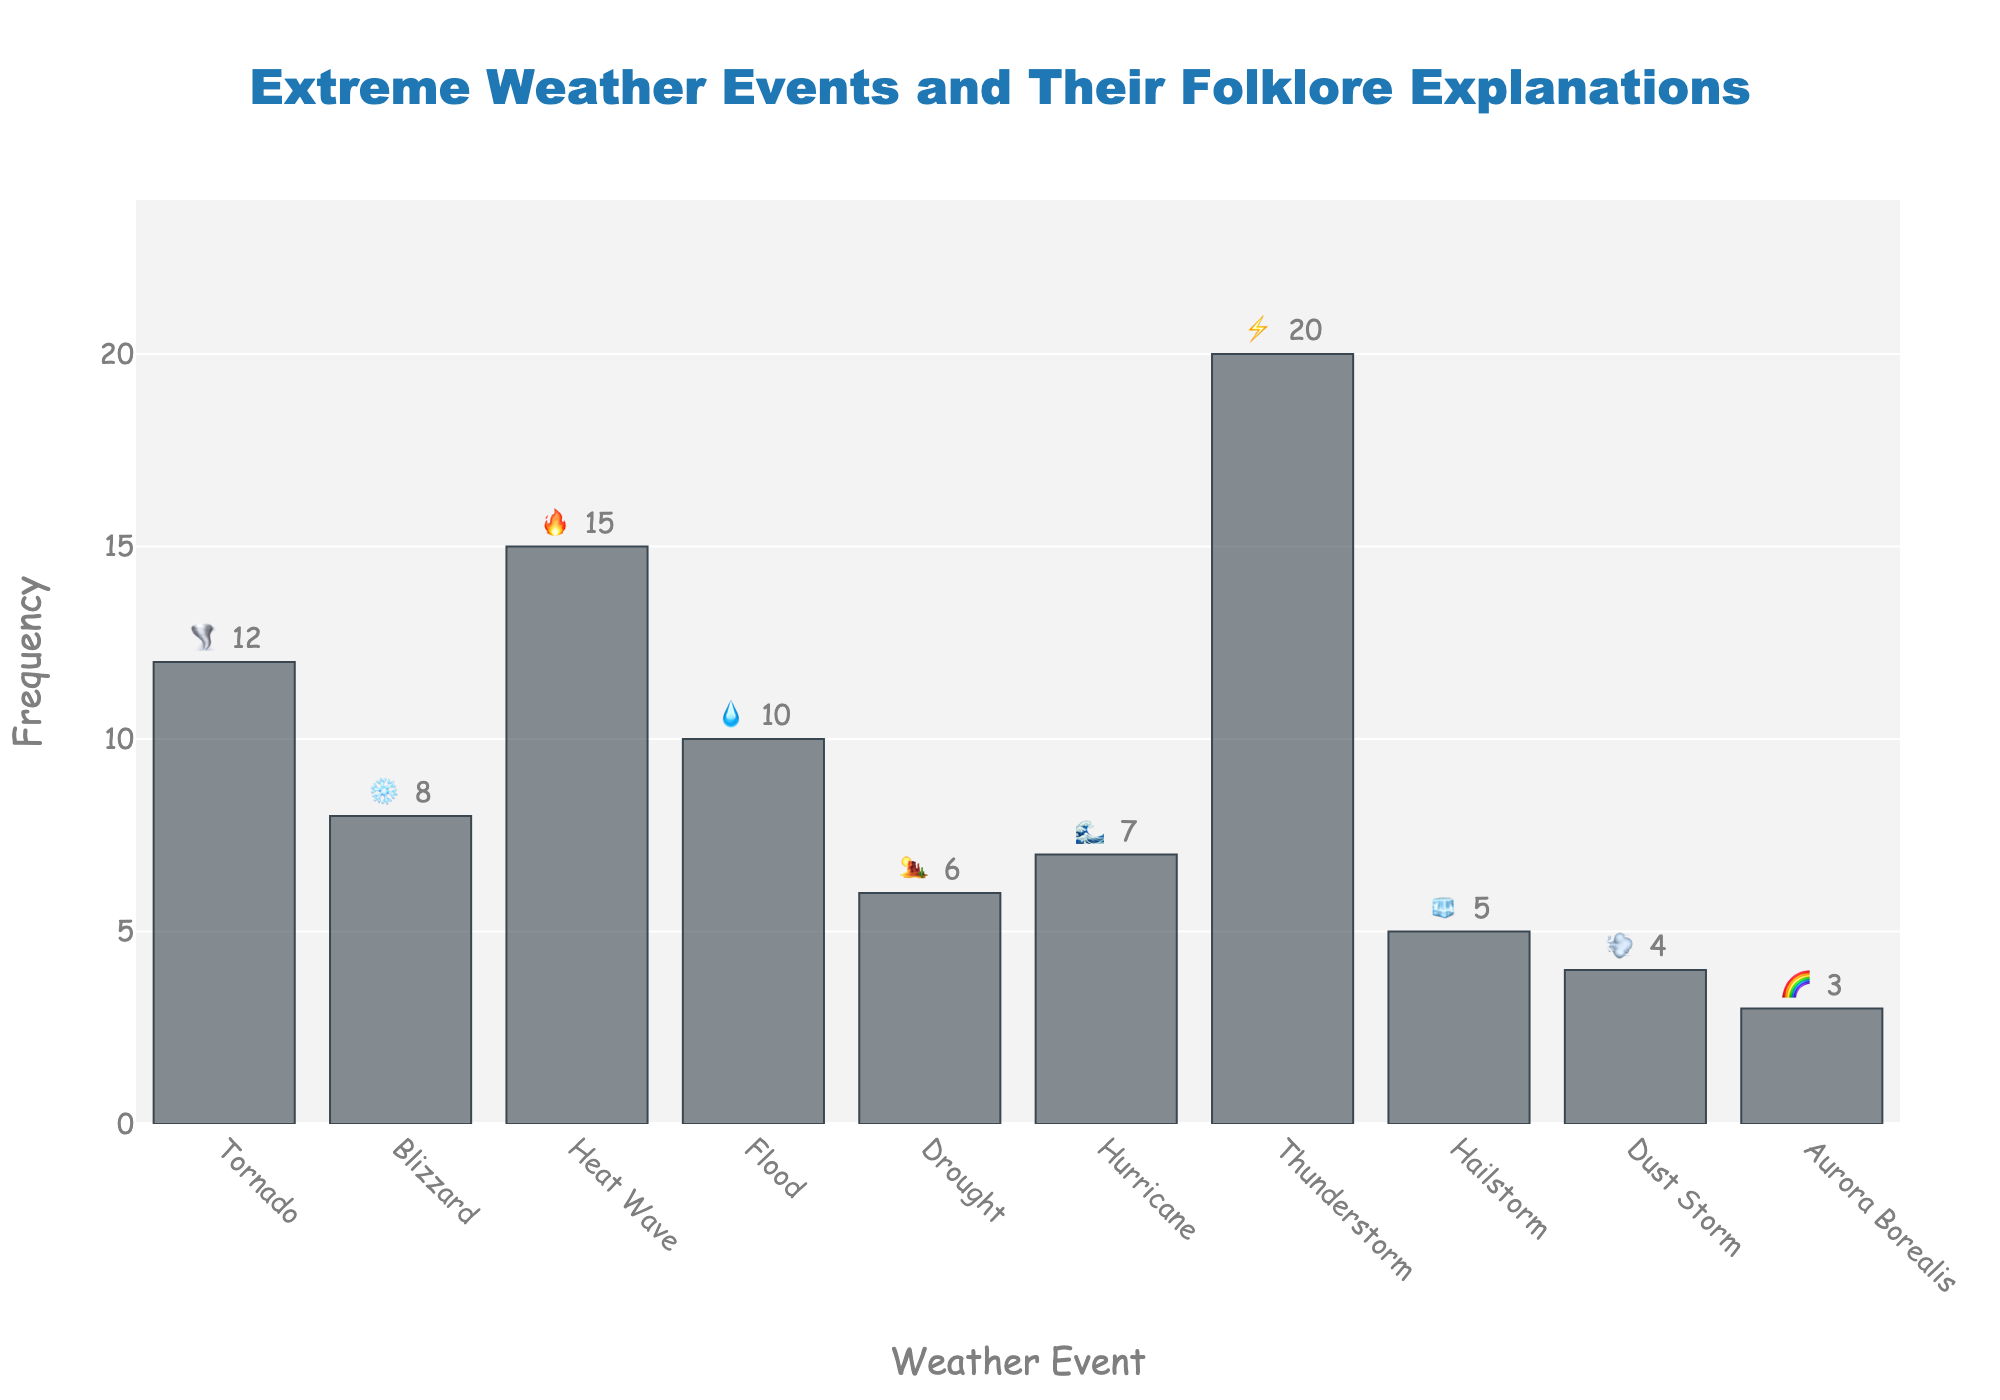What's the most frequent extreme weather event? The bar with the highest value indicates the most frequent event. The Thunderstorm bar is the tallest, denoting it appears 20 times.
Answer: Thunderstorm What is the total frequency of Tornado and Drought combined? Summing the values for Tornado (12) and Drought (6), we get 12 + 6 = 18.
Answer: 18 Which extreme weather event has the lowest frequency? The bar with the shortest length represents the lowest frequency. Aurora Borealis has a frequency of 3, the lowest among all.
Answer: Aurora Borealis How does the frequency of Hailstorm compare to that of Heat Wave? Observing the heights of the bars for Hailstorm and Heat Wave, Hailstorm has a frequency of 5 and Heat Wave has a frequency of 15, making Heat Wave more frequent.
Answer: Heat Wave is more frequent What are the folklore explanations for Blizzard and Hurricane? Hovering over the bars provides folklore explanations: Blizzard is "Old Man Winter's sneeze" and Hurricane is "Sea king's wrath."
Answer: Blizzard: Old Man Winter's sneeze, Hurricane: Sea king's wrath What's the total frequency of all extreme weather events combined? Adding up all the frequencies: 12 (Tornado) + 8 (Blizzard) + 15 (Heat Wave) + 10 (Flood) + 6 (Drought) + 7 (Hurricane) + 20 (Thunderstorm) + 5 (Hailstorm) + 4 (Dust Storm) + 3 (Aurora Borealis) = 90.
Answer: 90 Which event has the folklore explanation "Angry sky spirits dancing"? By referring to the hovertext for each bar, we see that Tornado has the folklore explanation "Angry sky spirits dancing."
Answer: Tornado Is the frequency of Flood higher or lower than the frequency of Hurricane? Comparing the heights of the Flood and Hurricane bars, Flood is at 10 and Hurricane is at 7, so Flood is higher.
Answer: Higher What is the average frequency of all listed extreme weather events? Summing all frequencies is 90, and there are 10 events. Division, 90 ÷ 10, gives an average of 9.0.
Answer: 9.0 